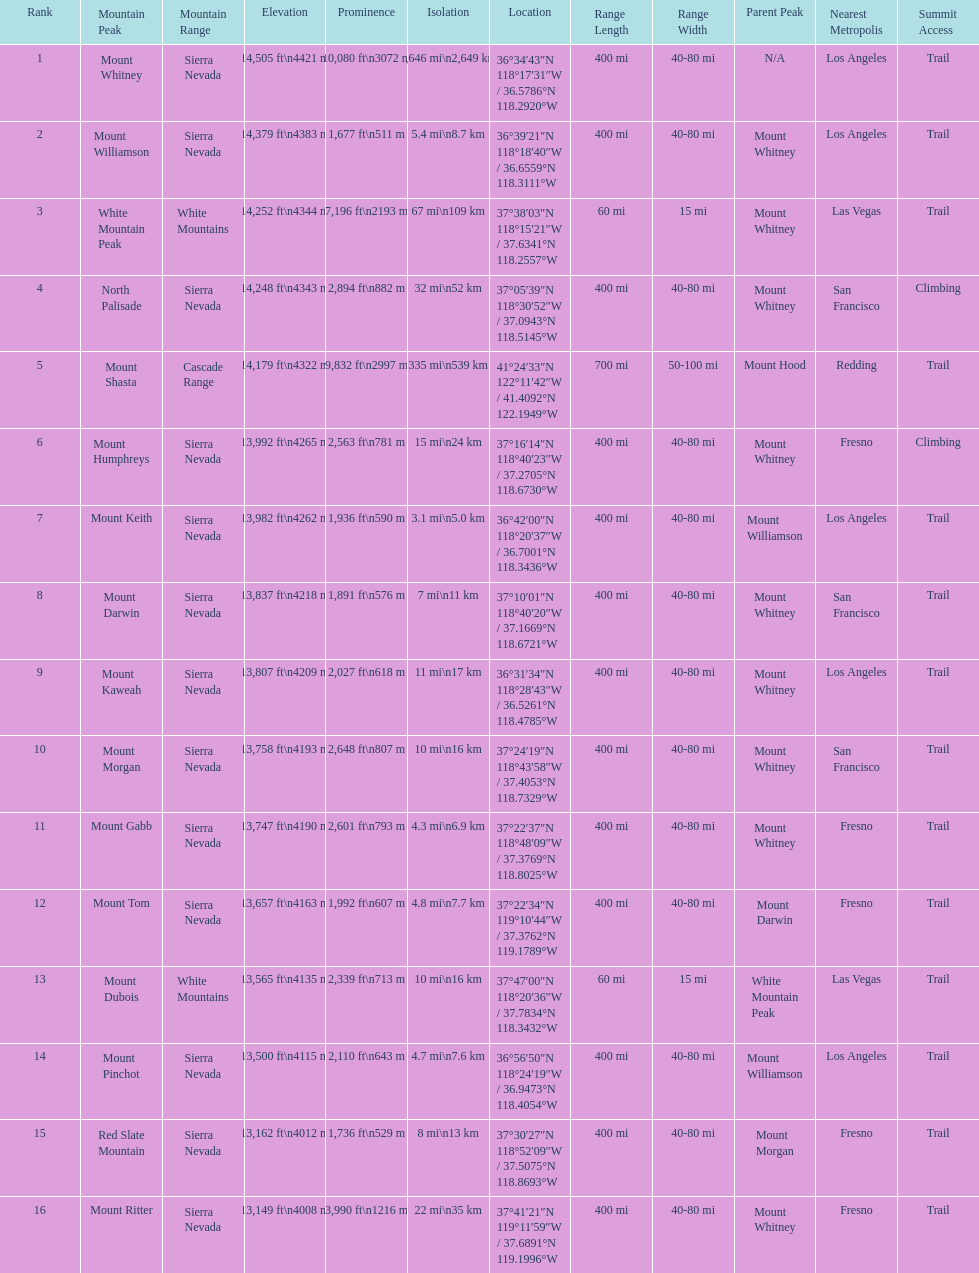Which mountain peaks are lower than 14,000 ft? Mount Humphreys, Mount Keith, Mount Darwin, Mount Kaweah, Mount Morgan, Mount Gabb, Mount Tom, Mount Dubois, Mount Pinchot, Red Slate Mountain, Mount Ritter. Are any of them below 13,500? if so, which ones? Red Slate Mountain, Mount Ritter. What's the lowest peak? 13,149 ft\n4008 m. Which one is that? Mount Ritter. 